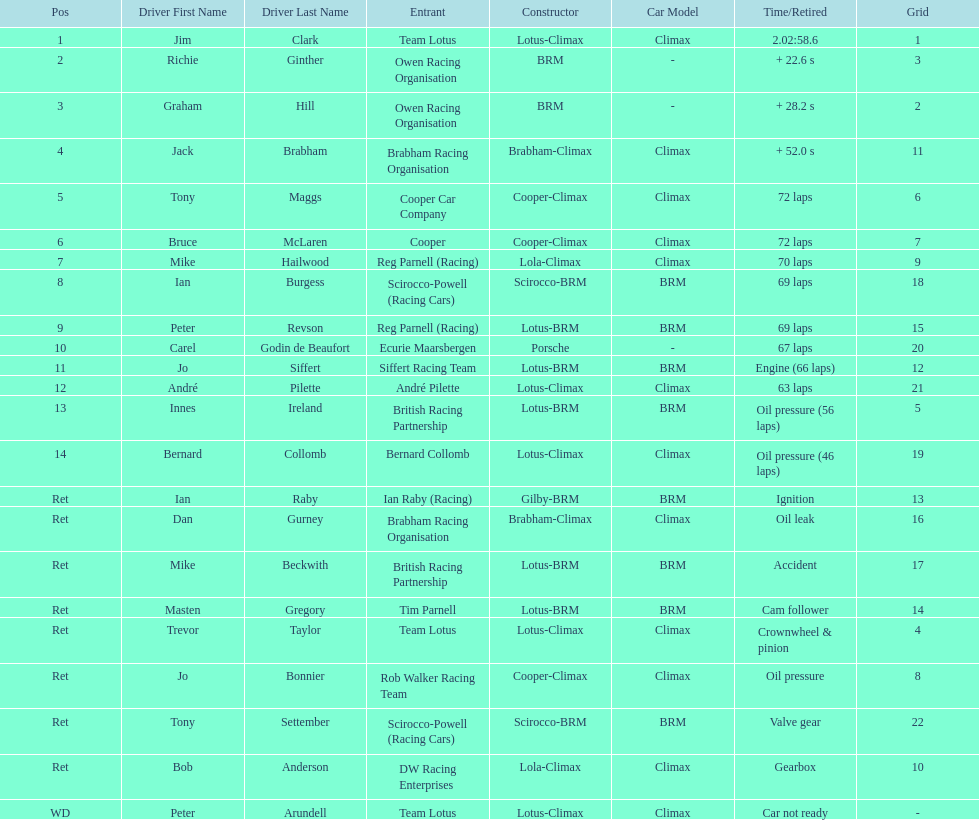Would you mind parsing the complete table? {'header': ['Pos', 'Driver First Name', 'Driver Last Name', 'Entrant', 'Constructor', 'Car Model', 'Time/Retired', 'Grid'], 'rows': [['1', 'Jim', 'Clark', 'Team Lotus', 'Lotus-Climax', 'Climax', '2.02:58.6', '1'], ['2', 'Richie', 'Ginther', 'Owen Racing Organisation', 'BRM', '-', '+ 22.6 s', '3'], ['3', 'Graham', 'Hill', 'Owen Racing Organisation', 'BRM', '-', '+ 28.2 s', '2'], ['4', 'Jack', 'Brabham', 'Brabham Racing Organisation', 'Brabham-Climax', 'Climax', '+ 52.0 s', '11'], ['5', 'Tony', 'Maggs', 'Cooper Car Company', 'Cooper-Climax', 'Climax', '72 laps', '6'], ['6', 'Bruce', 'McLaren', 'Cooper', 'Cooper-Climax', 'Climax', '72 laps', '7'], ['7', 'Mike', 'Hailwood', 'Reg Parnell (Racing)', 'Lola-Climax', 'Climax', '70 laps', '9'], ['8', 'Ian', 'Burgess', 'Scirocco-Powell (Racing Cars)', 'Scirocco-BRM', 'BRM', '69 laps', '18'], ['9', 'Peter', 'Revson', 'Reg Parnell (Racing)', 'Lotus-BRM', 'BRM', '69 laps', '15'], ['10', 'Carel', 'Godin de Beaufort', 'Ecurie Maarsbergen', 'Porsche', '-', '67 laps', '20'], ['11', 'Jo', 'Siffert', 'Siffert Racing Team', 'Lotus-BRM', 'BRM', 'Engine (66 laps)', '12'], ['12', 'André', 'Pilette', 'André Pilette', 'Lotus-Climax', 'Climax', '63 laps', '21'], ['13', 'Innes', 'Ireland', 'British Racing Partnership', 'Lotus-BRM', 'BRM', 'Oil pressure (56 laps)', '5'], ['14', 'Bernard', 'Collomb', 'Bernard Collomb', 'Lotus-Climax', 'Climax', 'Oil pressure (46 laps)', '19'], ['Ret', 'Ian', 'Raby', 'Ian Raby (Racing)', 'Gilby-BRM', 'BRM', 'Ignition', '13'], ['Ret', 'Dan', 'Gurney', 'Brabham Racing Organisation', 'Brabham-Climax', 'Climax', 'Oil leak', '16'], ['Ret', 'Mike', 'Beckwith', 'British Racing Partnership', 'Lotus-BRM', 'BRM', 'Accident', '17'], ['Ret', 'Masten', 'Gregory', 'Tim Parnell', 'Lotus-BRM', 'BRM', 'Cam follower', '14'], ['Ret', 'Trevor', 'Taylor', 'Team Lotus', 'Lotus-Climax', 'Climax', 'Crownwheel & pinion', '4'], ['Ret', 'Jo', 'Bonnier', 'Rob Walker Racing Team', 'Cooper-Climax', 'Climax', 'Oil pressure', '8'], ['Ret', 'Tony', 'Settember', 'Scirocco-Powell (Racing Cars)', 'Scirocco-BRM', 'BRM', 'Valve gear', '22'], ['Ret', 'Bob', 'Anderson', 'DW Racing Enterprises', 'Lola-Climax', 'Climax', 'Gearbox', '10'], ['WD', 'Peter', 'Arundell', 'Team Lotus', 'Lotus-Climax', 'Climax', 'Car not ready', '-']]} Who came in first? Jim Clark. 